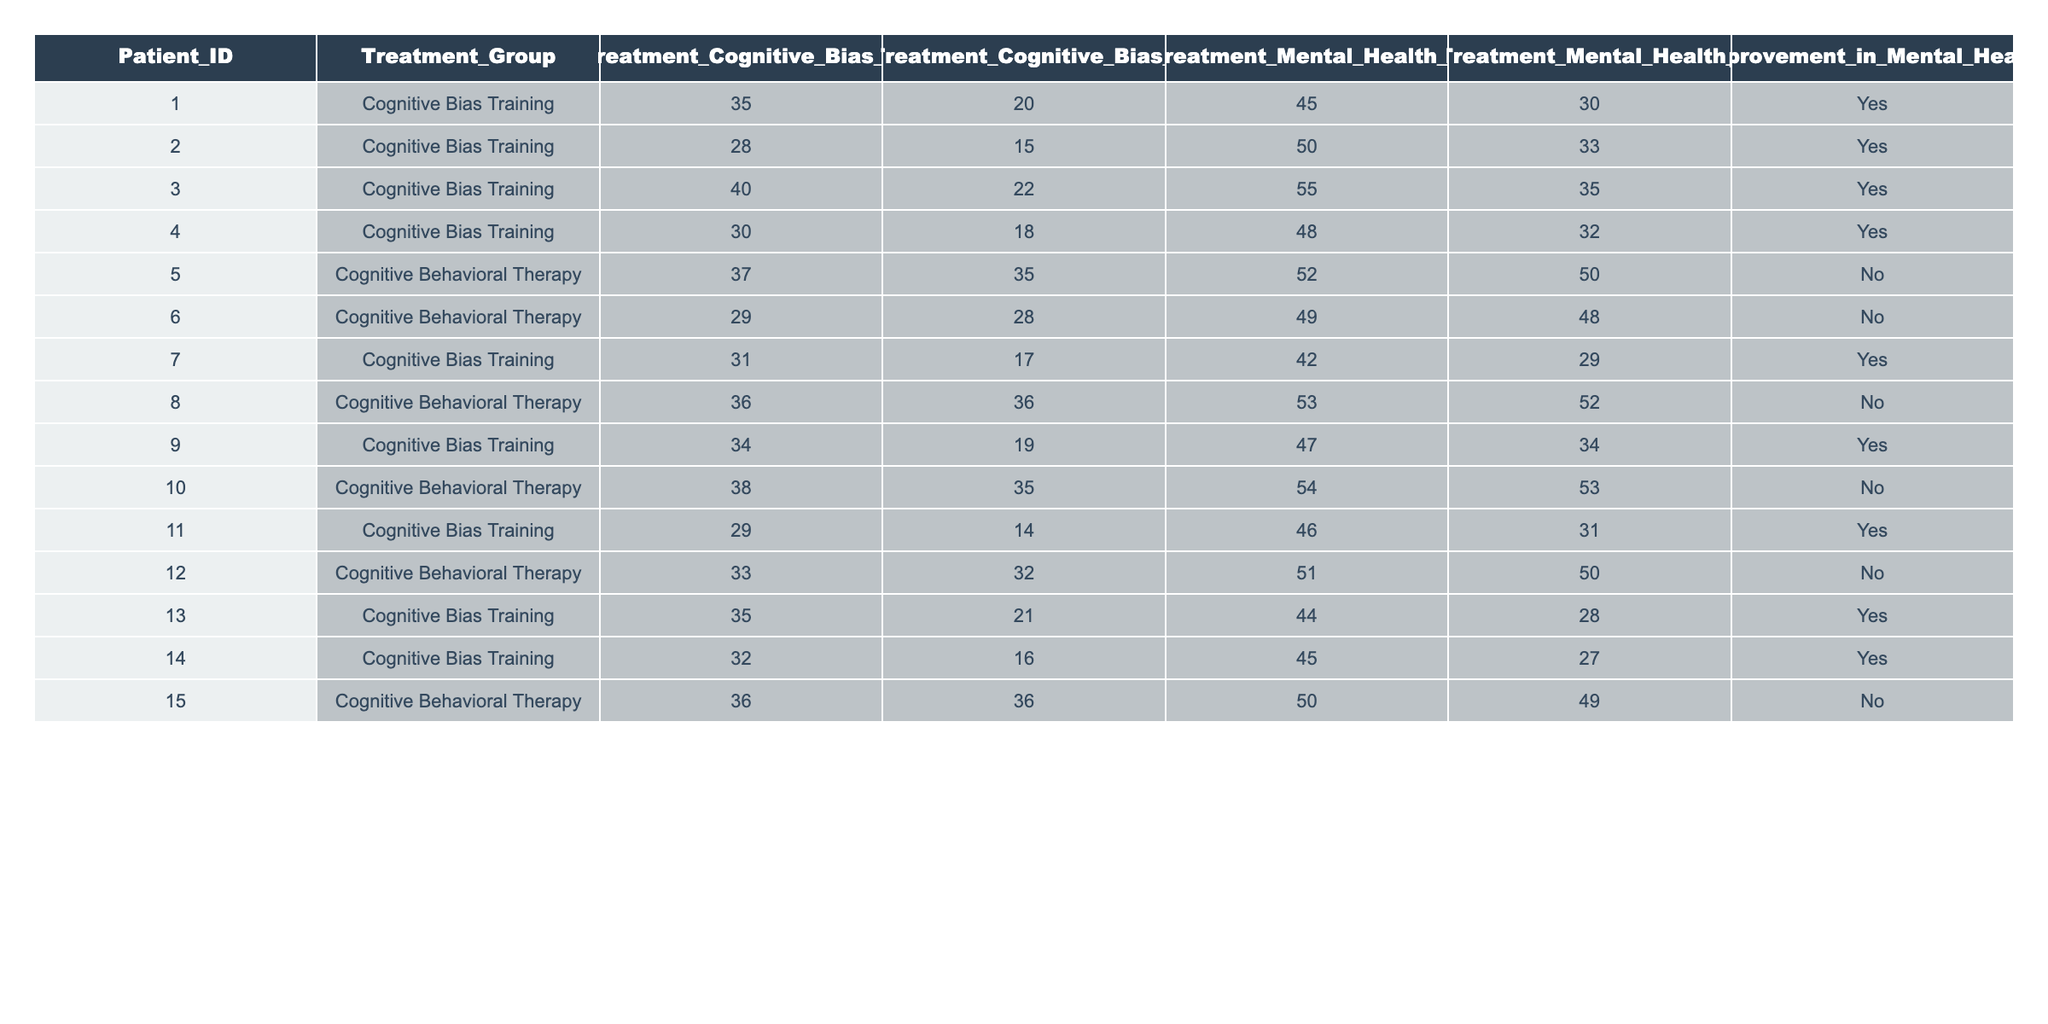What is the Pre-Treatment Cognitive Bias Score for Patient ID 002? The Pre-Treatment Cognitive Bias Score for Patient ID 002 can be found directly in the table under the appropriate column, which shows a score of 28.
Answer: 28 How many patients showed improvement in mental health after the treatment? To find the number of patients showing improvement, I counted the "Yes" entries in the Improvement in Mental Health column. There are 8 patients with "Yes".
Answer: 8 What was the Post-Treatment Mental Health Score for Patient ID 011? The Post-Treatment Mental Health Score for Patient ID 011 is located in the corresponding row under the Post_Treatment_Mental_Health_Score column, which indicates a score of 31.
Answer: 31 What is the average Pre-Treatment Mental Health Score for the Cognitive Behavioral Therapy group? There are 4 patients in the Cognitive Behavioral Therapy group with Pre-Treatment Mental Health Scores of 52, 49, 53, and 50. Summing them gives 52 + 49 + 53 + 50 = 204. The average is 204 divided by 4, resulting in 51.
Answer: 51 For which patient was the reduction in Cognitive Bias Score the highest? To determine which patient had the highest reduction in Cognitive Bias Score, I calculated the difference between Pre and Post-Treatment scores for each patient. Patient ID 001 had the highest reduction of 15 (35 - 20).
Answer: 001 Do patients in the Cognitive Bias Training group show a higher rate of improvement than those in the Cognitive Behavioral Therapy group? I identified the number of "Yes" entries for each group. The Cognitive Bias Training group has 8 improvements (Yes), while the Cognitive Behavioral Therapy group has 0 improvements (No). Therefore, the Cognitive Bias Training group shows a higher rate of improvement.
Answer: Yes What is the difference between the highest and lowest Post-Treatment Cognitive Bias Score in the Cognitive Bias Training group? After identifying the Post-Treatment Cognitive Bias Scores in the Cognitive Bias Training group, I found the highest score to be 22 and the lowest to be 14. The difference is 22 - 14 = 8.
Answer: 8 Which treatment had the lowest Pre-Treatment Cognitive Bias Score? By looking at the table, I see that the Cognitive Behavioral Therapy group has a Pre-Treatment Cognitive Bias Score of 29 for Patient ID 006, which is the lowest score in the entire table.
Answer: 29 